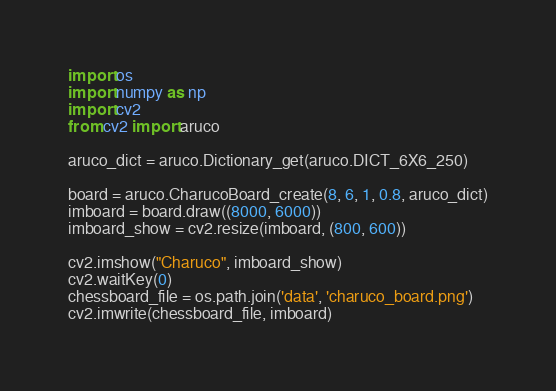Convert code to text. <code><loc_0><loc_0><loc_500><loc_500><_Python_>import os
import numpy as np
import cv2
from cv2 import aruco

aruco_dict = aruco.Dictionary_get(aruco.DICT_6X6_250)

board = aruco.CharucoBoard_create(8, 6, 1, 0.8, aruco_dict)
imboard = board.draw((8000, 6000))
imboard_show = cv2.resize(imboard, (800, 600))

cv2.imshow("Charuco", imboard_show)
cv2.waitKey(0)
chessboard_file = os.path.join('data', 'charuco_board.png')
cv2.imwrite(chessboard_file, imboard)
</code> 